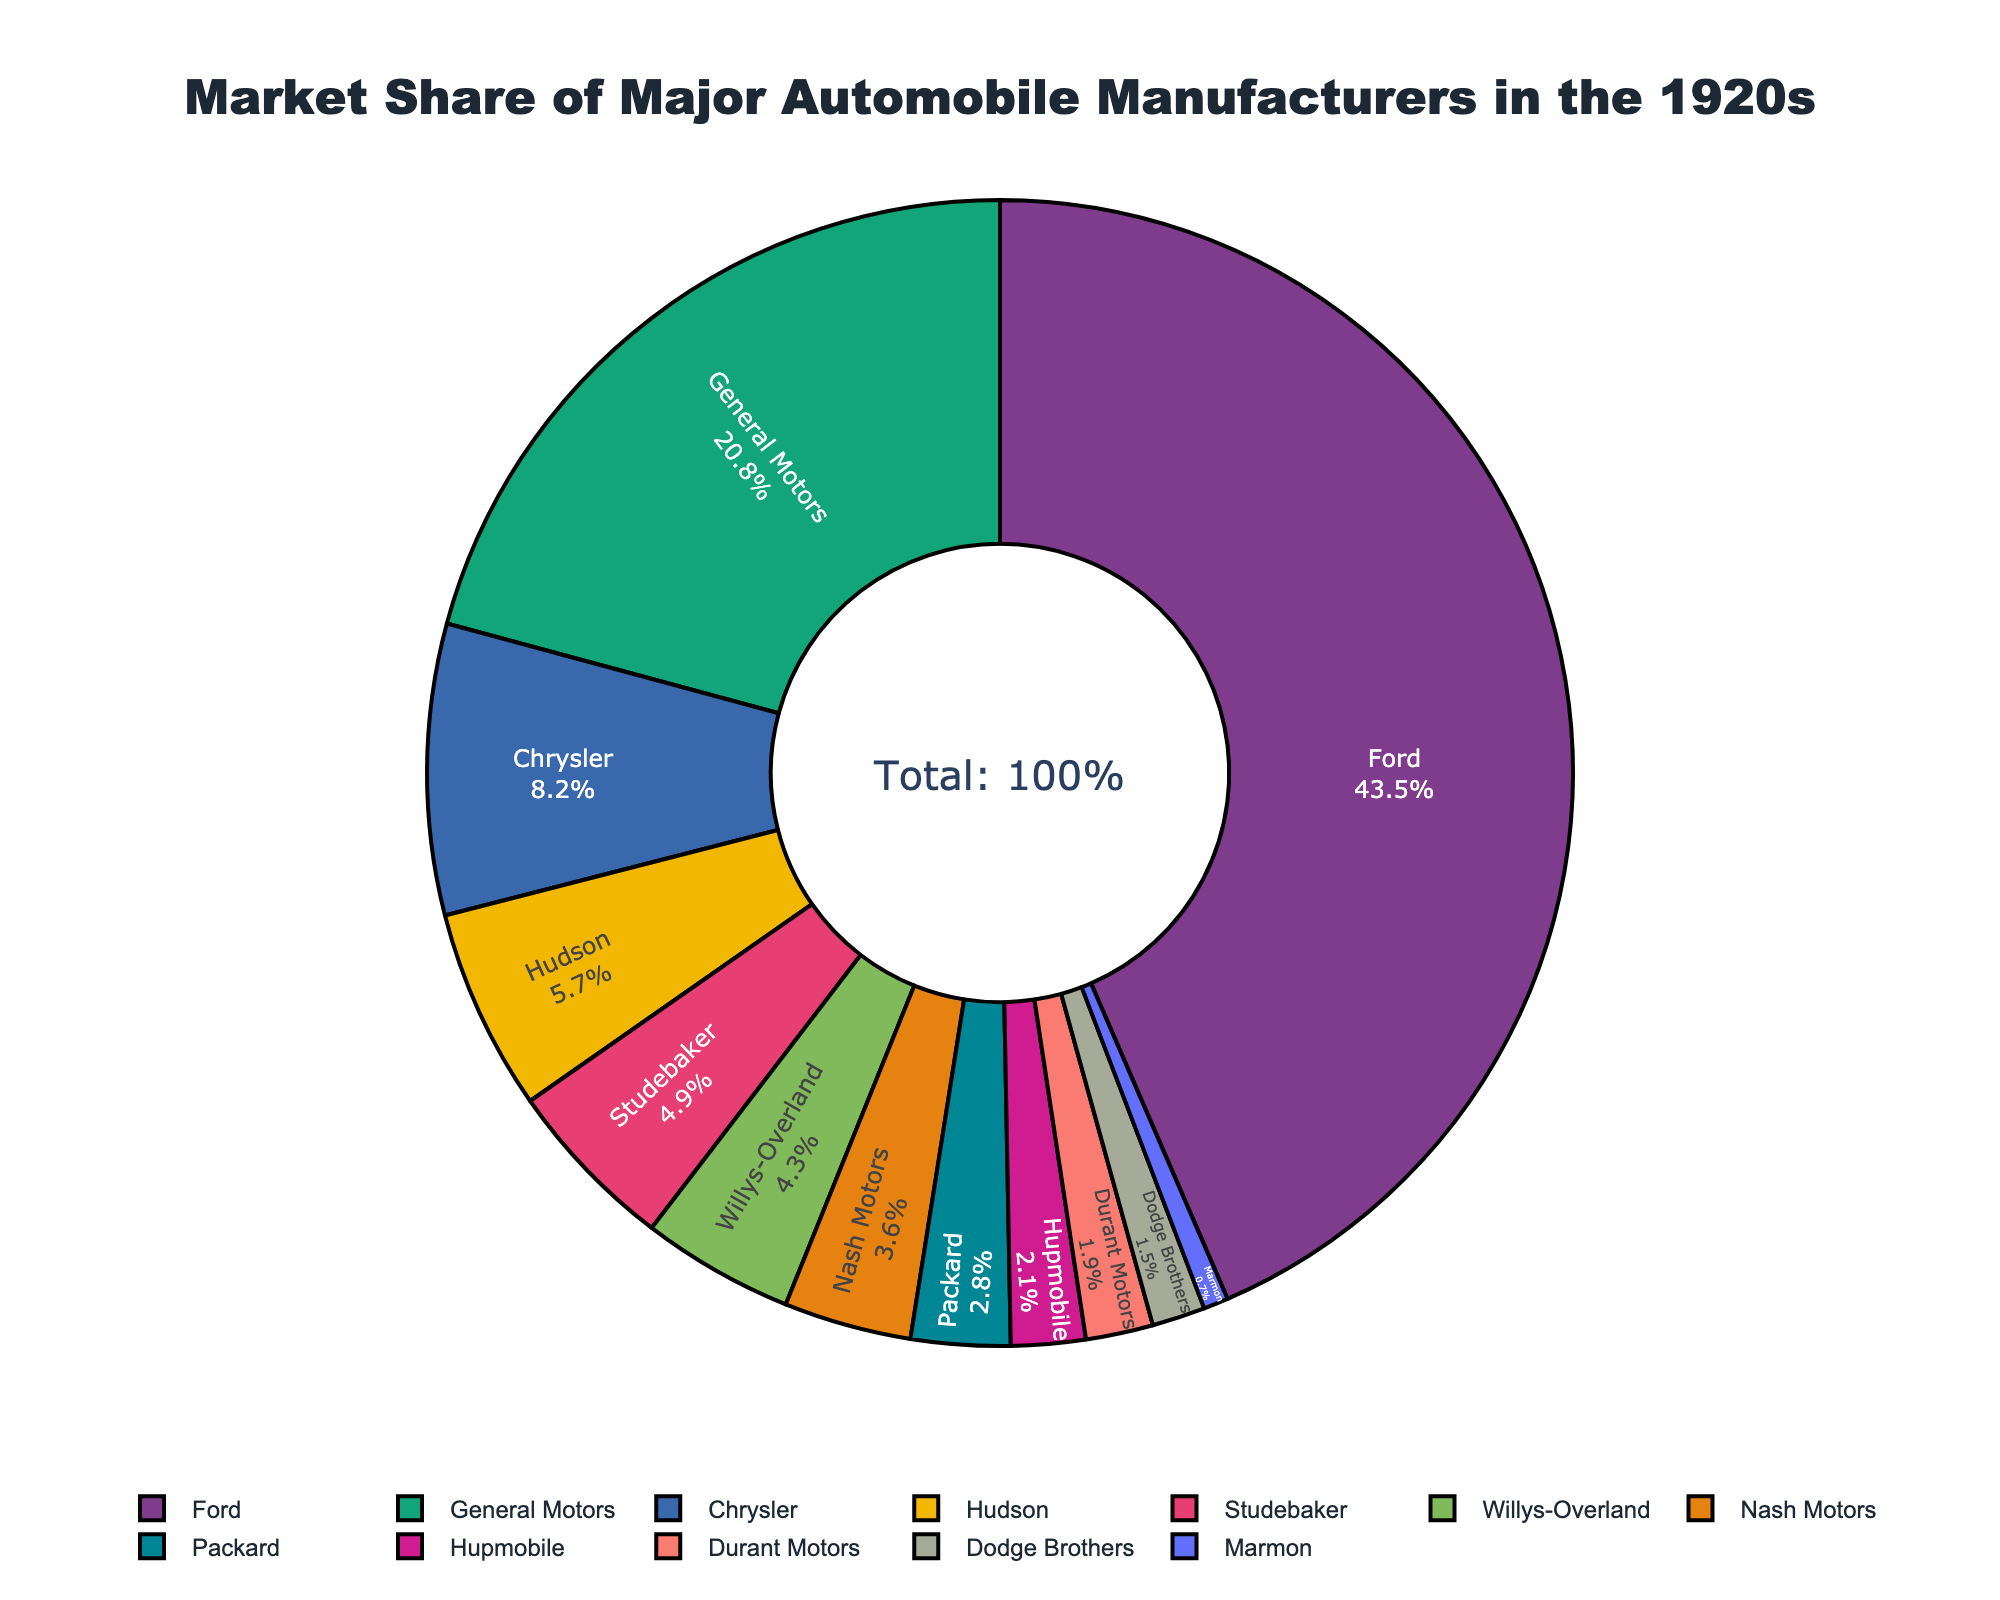Which manufacturer had the highest market share in the 1920s? Look at the manufacturer with the largest segment in the pie chart, which is usually centrally listed. Here, Ford has the largest segment.
Answer: Ford Which manufacturers had a market share less than 5%? Check the pie chart for segments smaller than 5%. According to the data, these are Nash Motors, Packard, Hupmobile, Durant Motors, Dodge Brothers, and Marmon.
Answer: Nash Motors, Packard, Hupmobile, Durant Motors, Dodge Brothers, Marmon How much more market share did Ford have compared to General Motors? Subtract the market share of General Motors from that of Ford. Ford has 43.5% and General Motors has 20.8%, so 43.5 - 20.8 = 22.7%.
Answer: 22.7% What is the total market share of the top three manufacturers? Add the market shares of the top three manufacturers: Ford (43.5%), General Motors (20.8%), and Chrysler (8.2%). 43.5 + 20.8 + 8.2 = 72.5%.
Answer: 72.5% Which two manufacturers had nearly equal market shares? Look for segments that appear similar in size. Hudson and Studebaker have close market shares: 5.7% and 4.9%, respectively.
Answer: Hudson, Studebaker Which manufacturer had the smallest market share in the 1920s? Look at the smallest segment in the pie chart. Here, Marmon has the smallest segment.
Answer: Marmon What is the combined market share of Willys-Overland and Nash Motors? Add the market shares of Willys-Overland (4.3%) and Nash Motors (3.6%). 4.3 + 3.6 = 7.9%.
Answer: 7.9% How does the market share of Hudson compare to that of Nash Motors? Compare the segments for Hudson and Nash Motors. Hudson has 5.7% and Nash Motors has 3.6%, so Hudson has a higher market share.
Answer: Hudson has a higher market share What is the average market share of the bottom five manufacturers? Add the market shares of the bottom five manufacturers and divide by 5. Durants Motors (1.9%), Dodge Brothers (1.5%), Marmon (0.7%), plus two more found in the smallest segments. (4.9% + 4.3% + 3.6% + 2.8% + 2.1%) / 5 = 2.74%.
Answer: 2.74% Which manufacturer forms the second largest segment in the pie chart? Identify the second largest segment visually. General Motors is the second largest segment after Ford.
Answer: General Motors 